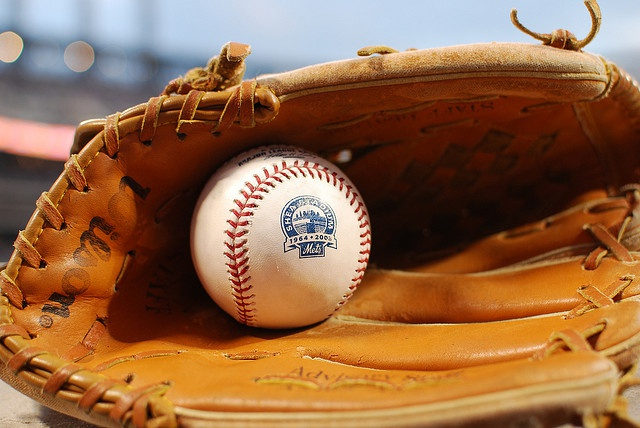Describe the objects in this image and their specific colors. I can see baseball glove in lightblue, maroon, black, orange, and brown tones and sports ball in lightblue, ivory, tan, and red tones in this image. 